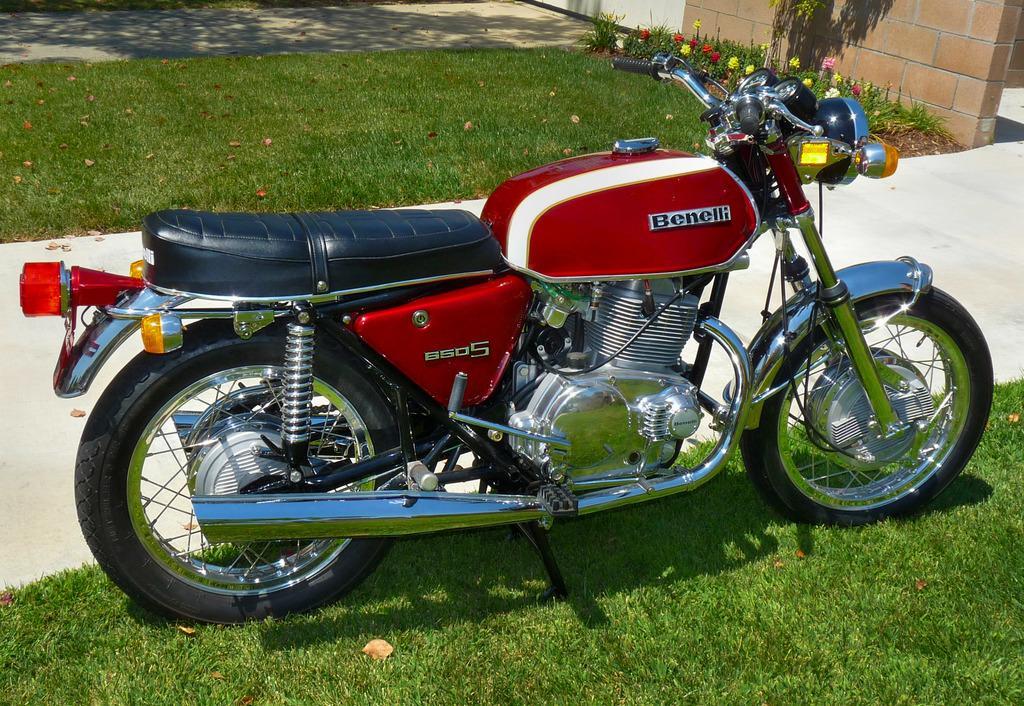Describe this image in one or two sentences. In this image, we can see a motor bike is parked on the grass. Behind the bike, there is a walkway. Top of the image, we can see flowers, plants, wall and grass. 